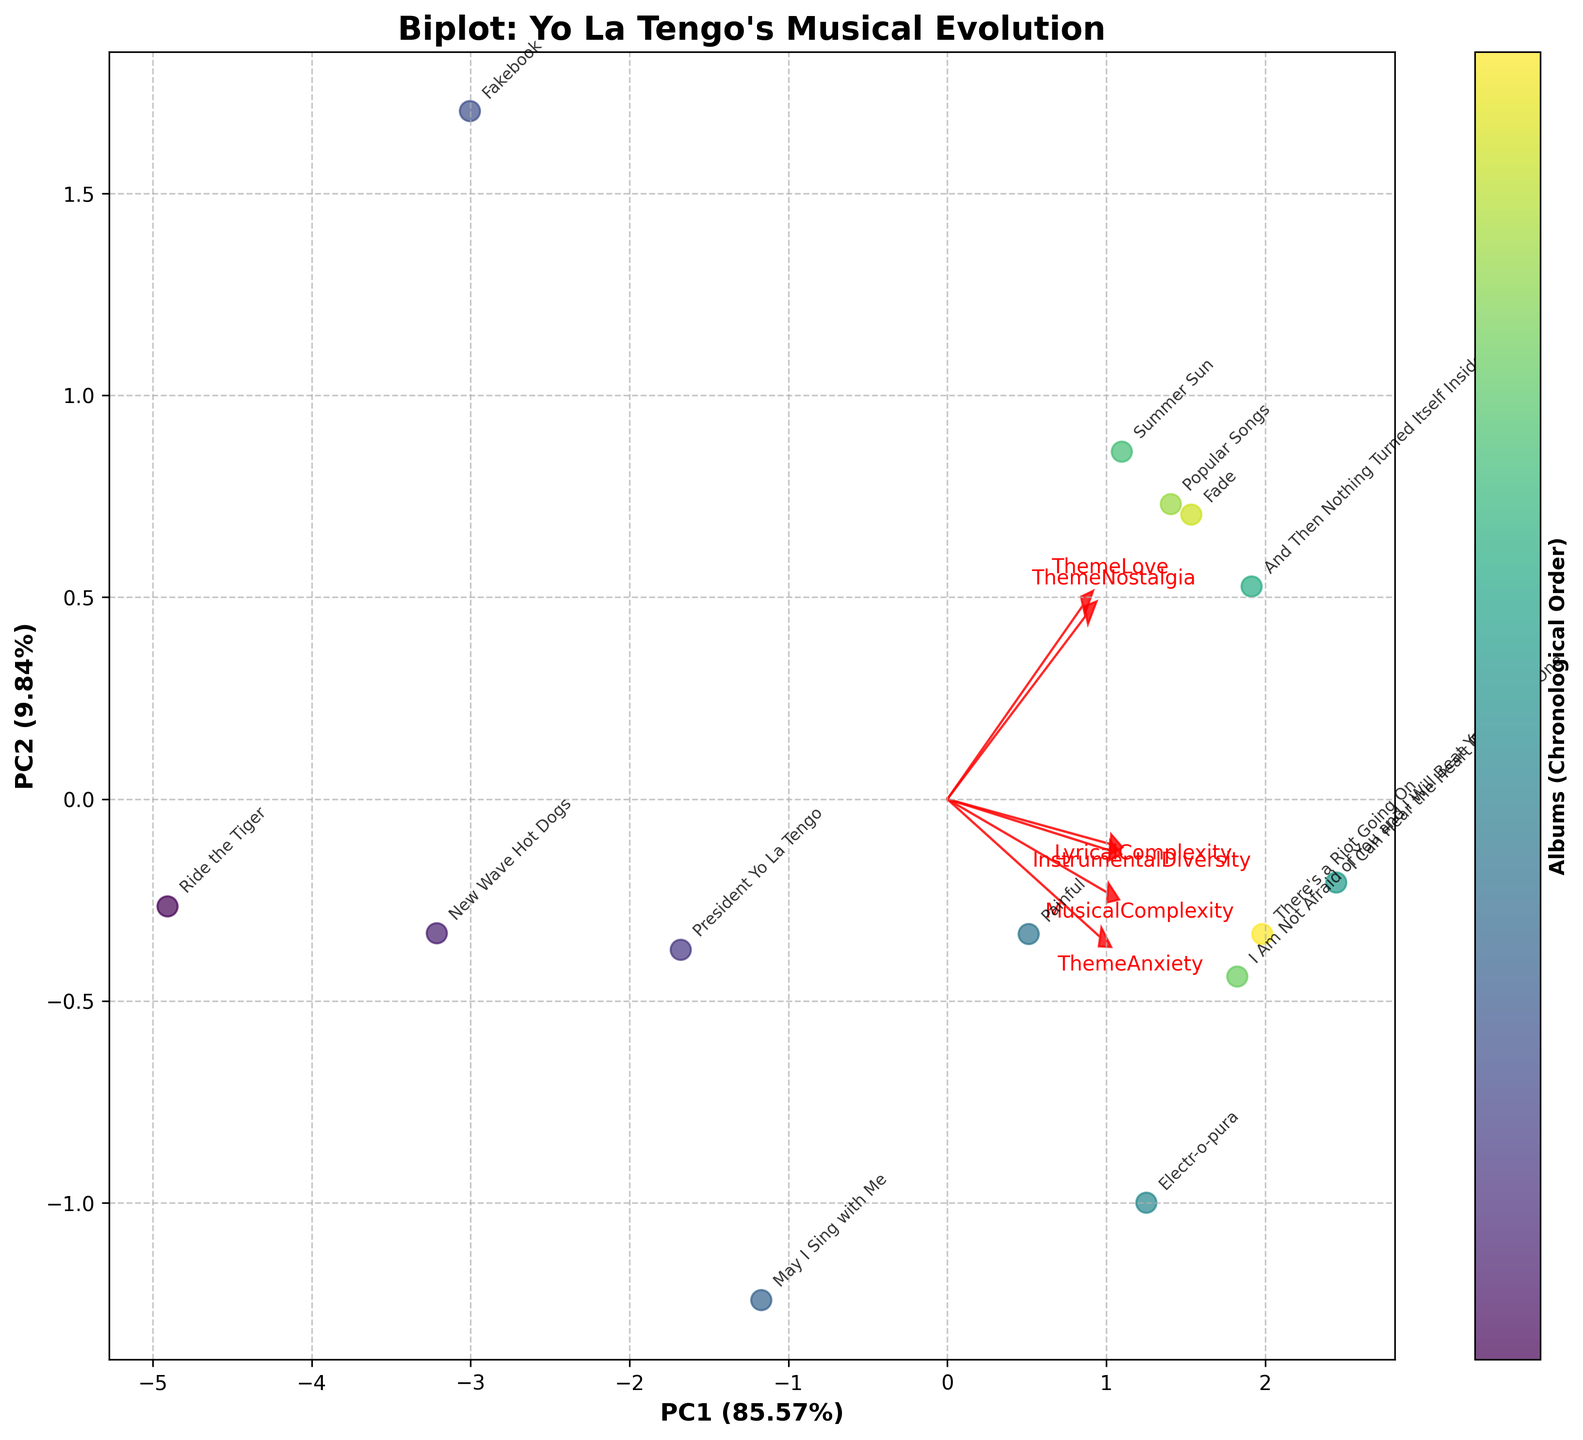How many albums are depicted in the biplot? To determine the number of albums, simply count the individual data points (scattered points) on the plot. Each point represents an album.
Answer: 14 What does PC1 represent in terms of explained variance? The x-axis represents the first principal component (PC1). You can see its percentage share of the total variance in the axis label, which reads something like "PC1 (XX.XX%)".
Answer: ~51% Which album appears to have the highest Lyrical Complexity and Musical Complexity combined? Look for the album point that lies furthest along the arrow direction marked with "LyricalComplexity" and "MusicalComplexity". The album with the combination of the highest values will be closest to the arrow tip.
Answer: "I Can Hear the Heart Beating as One" Which factor contributes more to the spread along PC1, ThemeLove or InstrumentalDiversity? Observe the length and direction of the arrows for "ThemeLove" and "InstrumentalDiversity". The arrow that is longer and more aligned with the PC1 axis contributes more to its variance.
Answer: InstrumentalDiversity How are "ThemeNostalgia" and "ThemeAnxiety" related within the albums? Check the direction and relative position of the arrows for "ThemeNostalgia" and "ThemeAnxiety". Their orientation relative to each other shows their relationship. If they are pointing in similar directions, they are positively correlated; if in opposite directions, they are negatively correlated.
Answer: Positively correlated Which album has the highest association with "ThemeNostalgia"? Find the data point (album) closest to the tip of the "ThemeNostalgia" arrow. This tells you which album has the highest value on this theme.
Answer: "Summer Sun" 